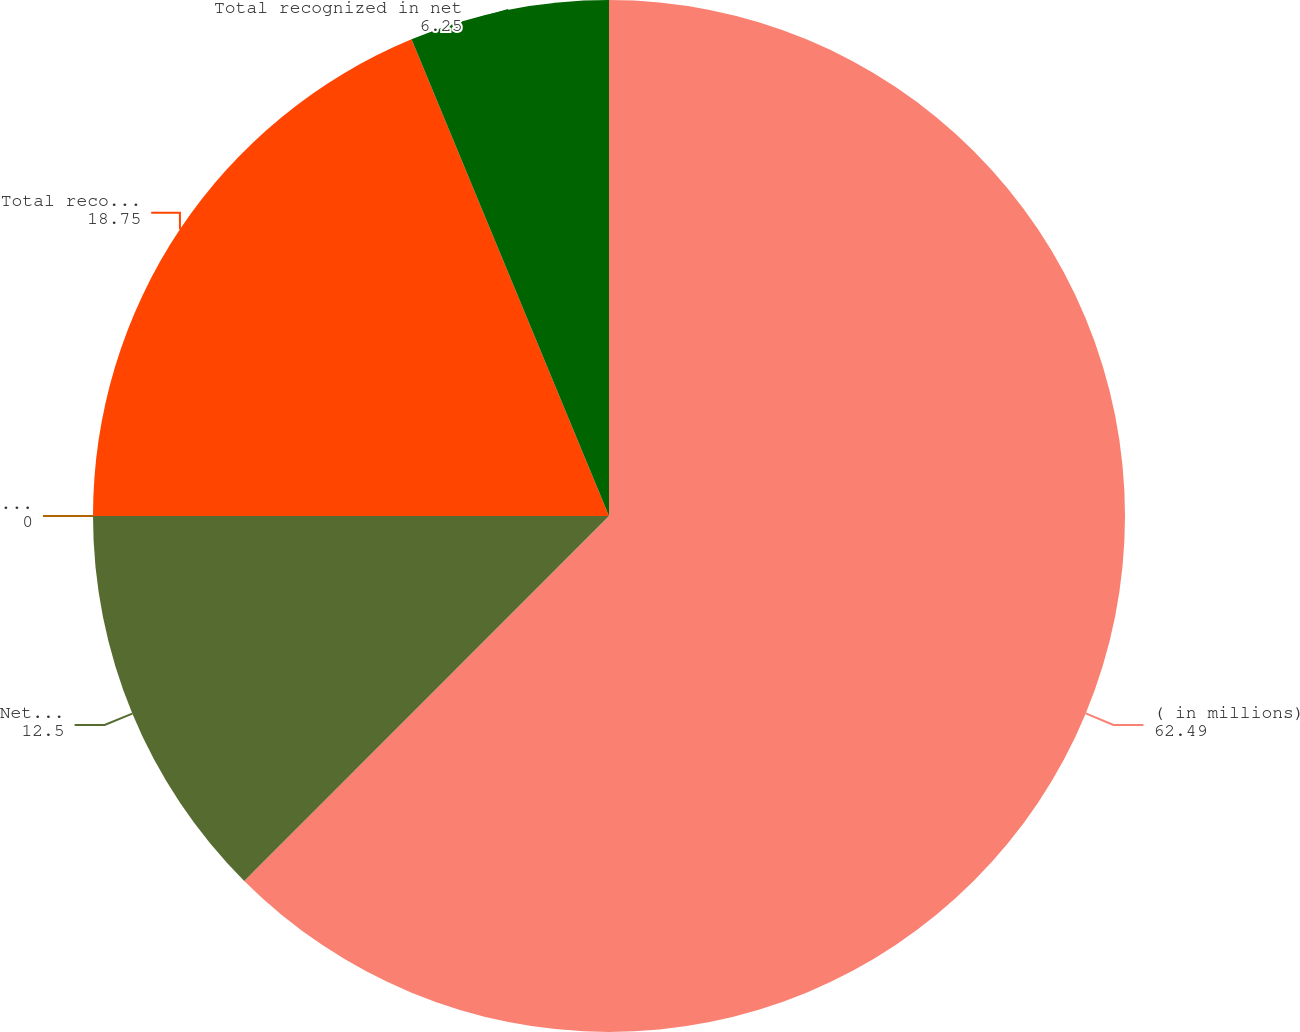<chart> <loc_0><loc_0><loc_500><loc_500><pie_chart><fcel>( in millions)<fcel>Net loss (gain) arising during<fcel>Amortization of prior service<fcel>Total recognized in other<fcel>Total recognized in net<nl><fcel>62.49%<fcel>12.5%<fcel>0.0%<fcel>18.75%<fcel>6.25%<nl></chart> 